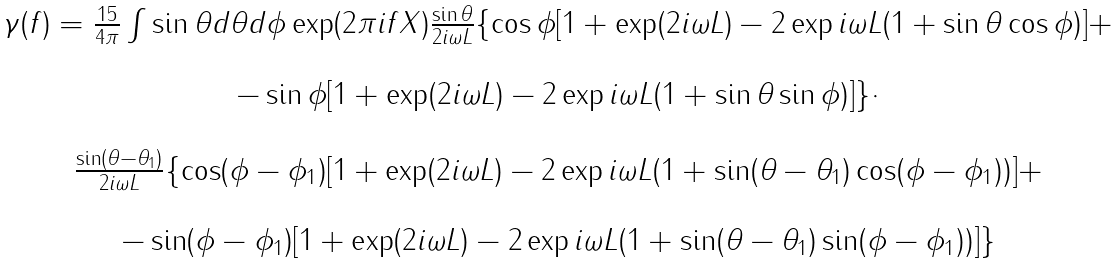<formula> <loc_0><loc_0><loc_500><loc_500>\begin{array} { c } \gamma ( f ) = \frac { 1 5 } { 4 \pi } \int \sin \theta d \theta d \phi \exp ( 2 \pi i f X ) \frac { \sin \theta } { 2 i \omega L } \{ \cos \phi [ 1 + \exp ( 2 i \omega L ) - 2 \exp i \omega L ( 1 + \sin \theta \cos \phi ) ] + \\ \\ - \sin \phi [ 1 + \exp ( 2 i \omega L ) - 2 \exp i \omega L ( 1 + \sin \theta \sin \phi ) ] \} \cdot \\ \\ \frac { \sin ( \theta - \theta _ { 1 } ) } { 2 i \omega L } \{ \cos ( \phi - \phi _ { 1 } ) [ 1 + \exp ( 2 i \omega L ) - 2 \exp i \omega L ( 1 + \sin ( \theta - \theta _ { 1 } ) \cos ( \phi - \phi _ { 1 } ) ) ] + \\ \\ - \sin ( \phi - \phi _ { 1 } ) [ 1 + \exp ( 2 i \omega L ) - 2 \exp i \omega L ( 1 + \sin ( \theta - \theta _ { 1 } ) \sin ( \phi - \phi _ { 1 } ) ) ] \} \end{array}</formula> 